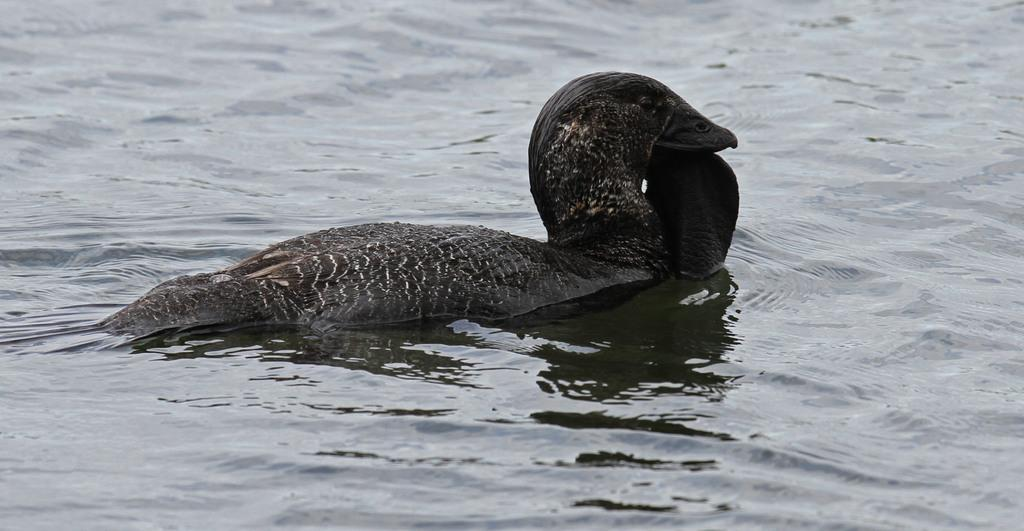What type of animal can be seen in the image? There is a black color bird in the image. Where is the bird located in the image? The bird is in the water. What type of scarf is the bird wearing in the image? There is no scarf present in the image, as birds do not wear clothing. 